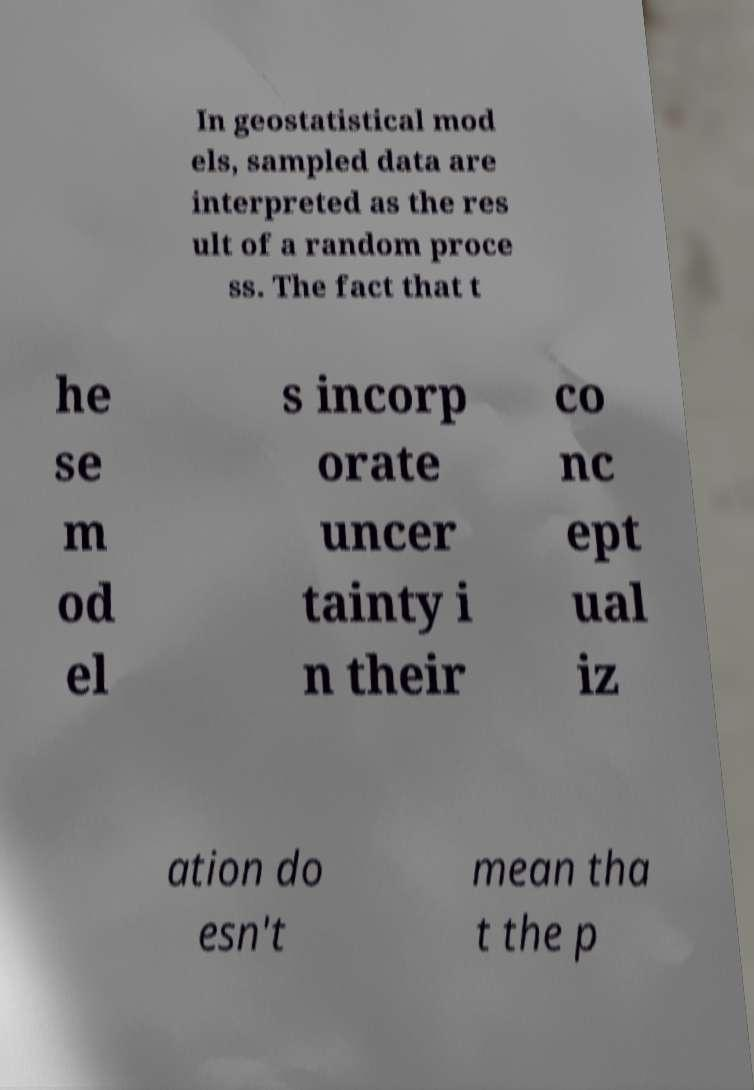Can you read and provide the text displayed in the image?This photo seems to have some interesting text. Can you extract and type it out for me? In geostatistical mod els, sampled data are interpreted as the res ult of a random proce ss. The fact that t he se m od el s incorp orate uncer tainty i n their co nc ept ual iz ation do esn't mean tha t the p 